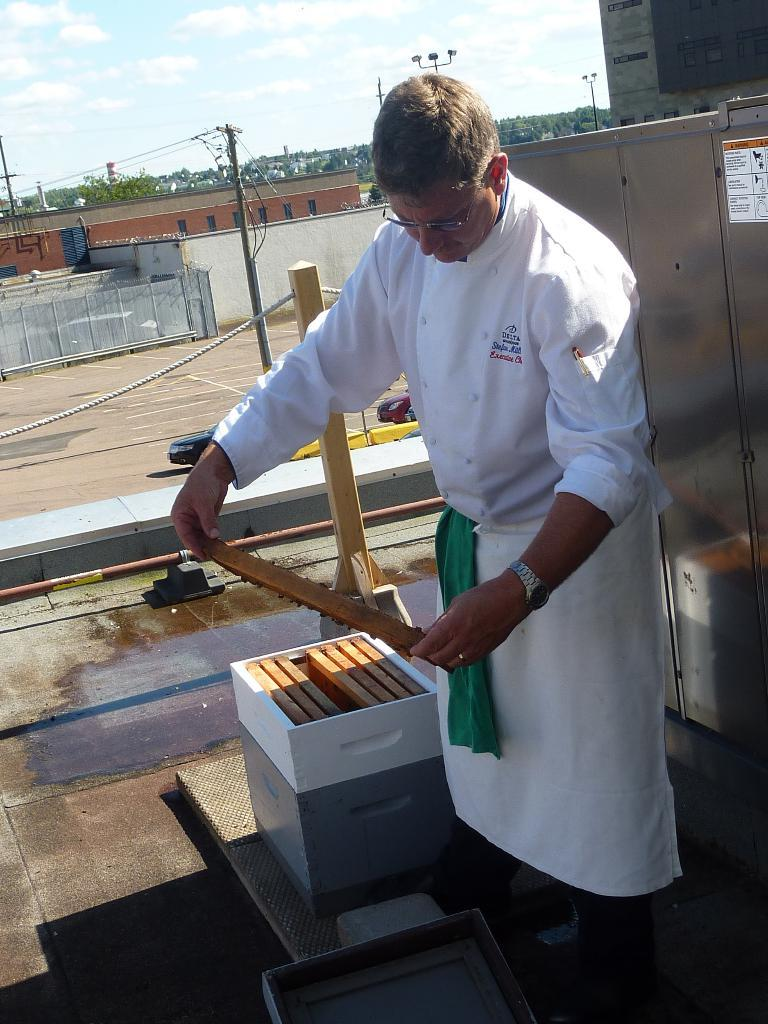What can be seen in the image? There is a person in the image. What is the person holding in their hand? The person is holding an object in their hand. What can be seen in the distance in the image? There are roads, buildings, and electric poles visible in the background of the image. Can you see any boats or a channel in the image? No, there are no boats or a channel present in the image. Is there a rabbit visible in the image? No, there is no rabbit present in the image. 